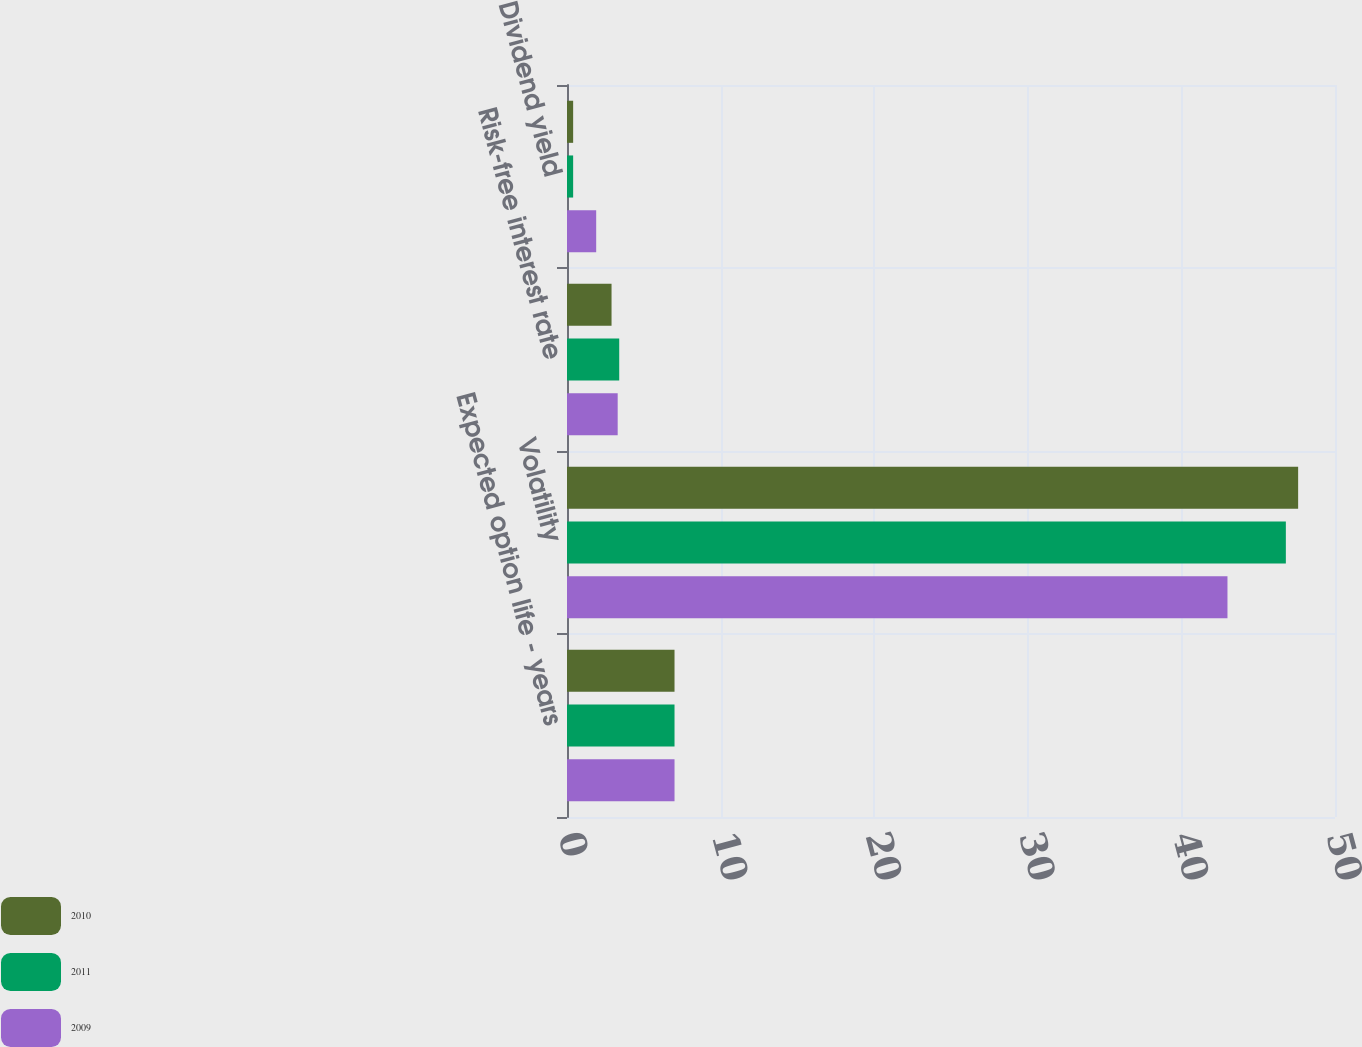<chart> <loc_0><loc_0><loc_500><loc_500><stacked_bar_chart><ecel><fcel>Expected option life - years<fcel>Volatility<fcel>Risk-free interest rate<fcel>Dividend yield<nl><fcel>2010<fcel>7<fcel>47.6<fcel>2.9<fcel>0.4<nl><fcel>2011<fcel>7<fcel>46.8<fcel>3.4<fcel>0.4<nl><fcel>2009<fcel>7<fcel>43<fcel>3.3<fcel>1.9<nl></chart> 